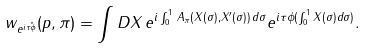Convert formula to latex. <formula><loc_0><loc_0><loc_500><loc_500>w _ { e ^ { i \tau \hat { \phi } } } ( p , \pi ) = \int D X \, e ^ { i \int _ { 0 } ^ { 1 } \, A _ { \pi } ( X ( \sigma ) , X ^ { \prime } ( \sigma ) ) \, d \sigma } e ^ { i \tau \phi ( \int _ { 0 } ^ { 1 } X ( \sigma ) d \sigma ) } .</formula> 